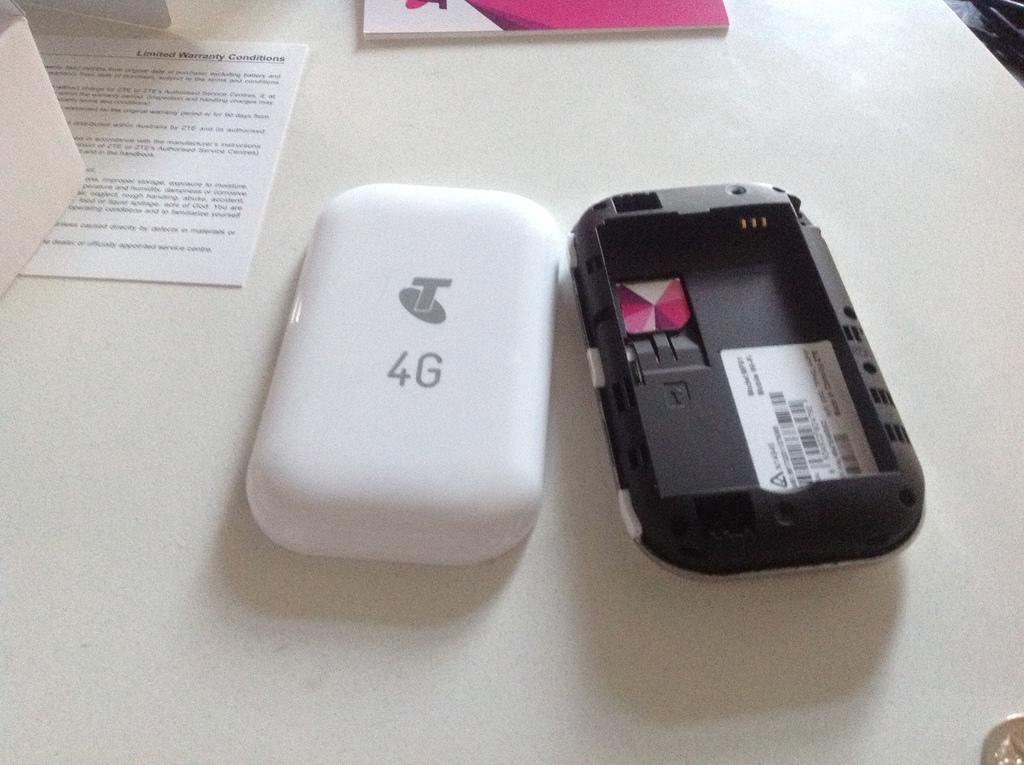<image>
Create a compact narrative representing the image presented. a white cell phone with a T and 4G on the back cover 